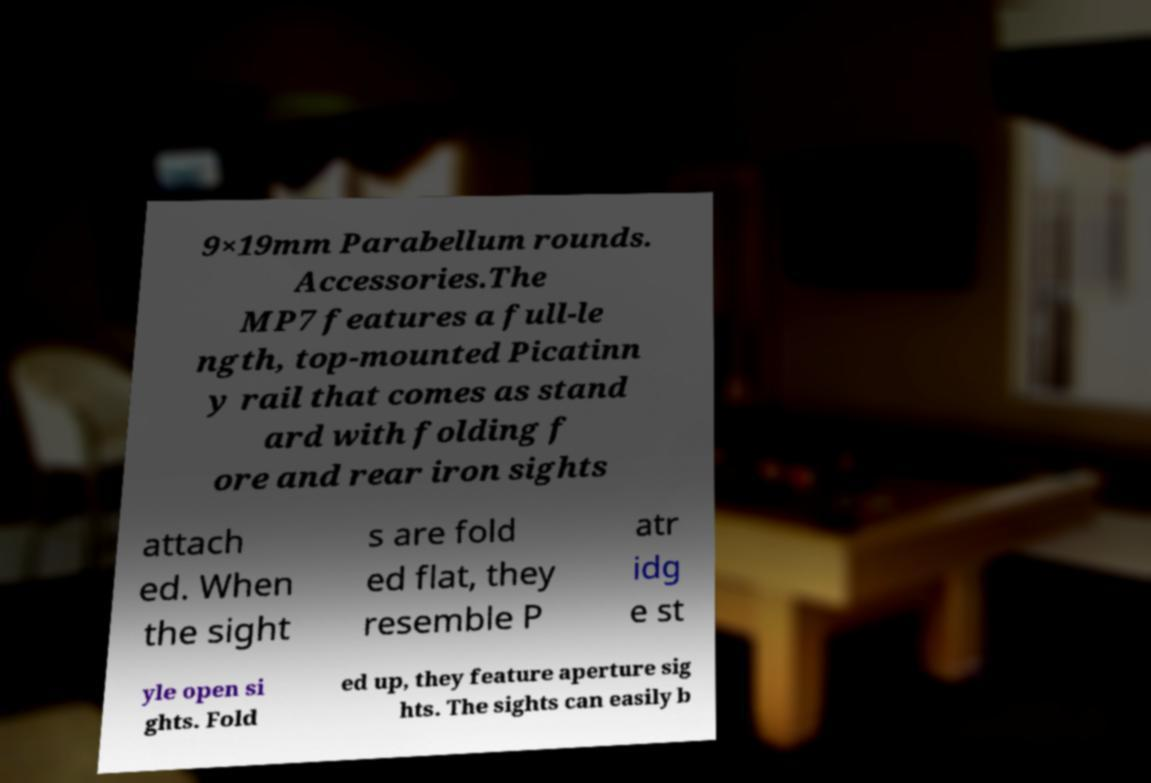What messages or text are displayed in this image? I need them in a readable, typed format. 9×19mm Parabellum rounds. Accessories.The MP7 features a full-le ngth, top-mounted Picatinn y rail that comes as stand ard with folding f ore and rear iron sights attach ed. When the sight s are fold ed flat, they resemble P atr idg e st yle open si ghts. Fold ed up, they feature aperture sig hts. The sights can easily b 